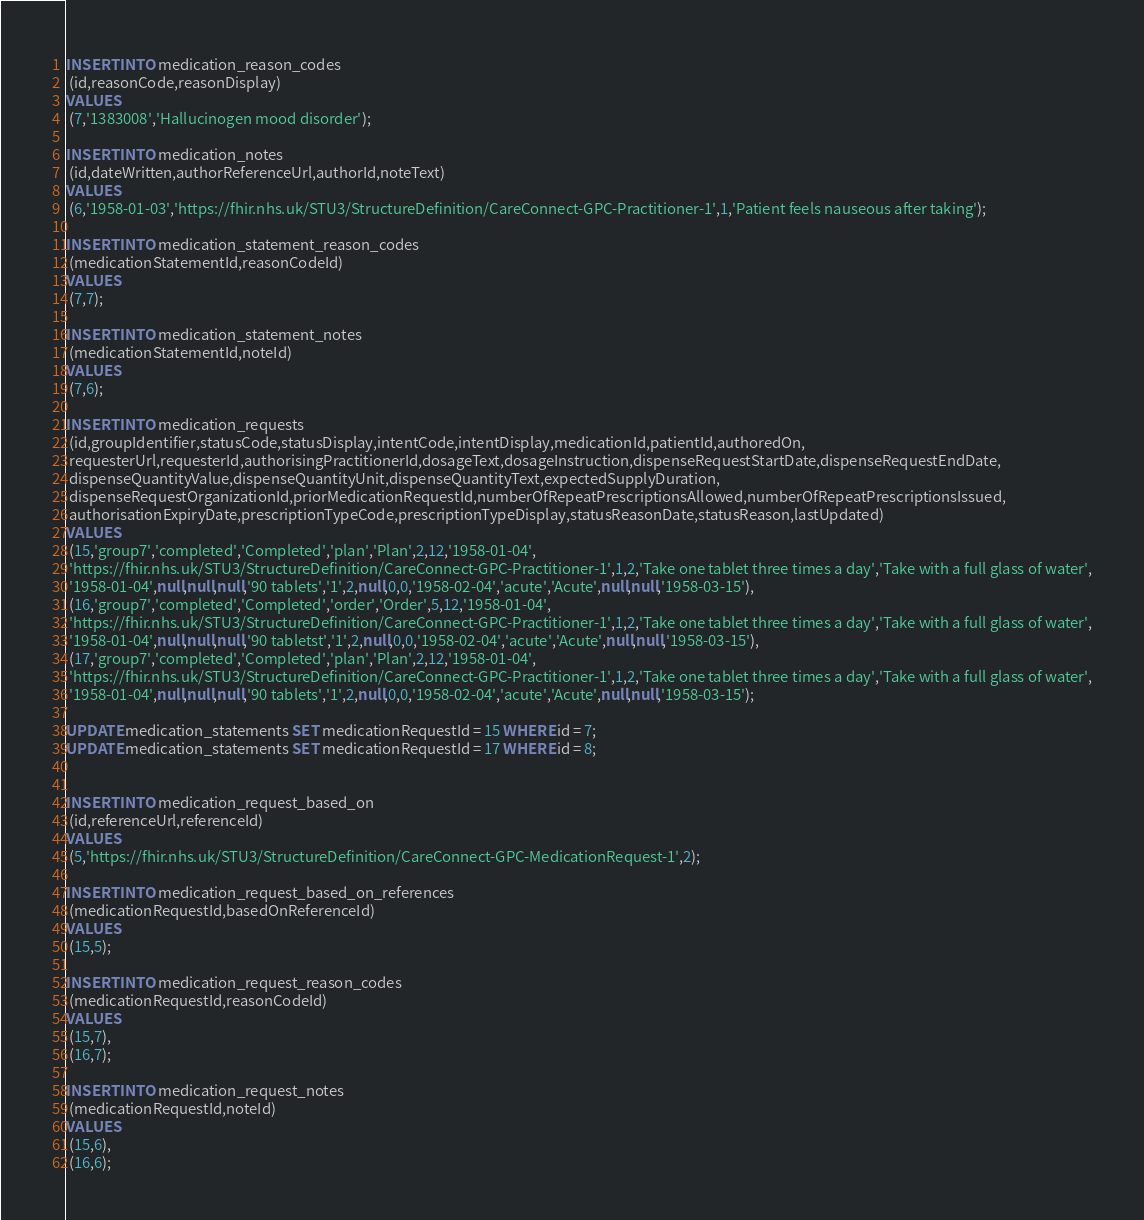Convert code to text. <code><loc_0><loc_0><loc_500><loc_500><_SQL_>INSERT INTO medication_reason_codes
 (id,reasonCode,reasonDisplay)
VALUES
 (7,'1383008','Hallucinogen mood disorder');

INSERT INTO medication_notes
 (id,dateWritten,authorReferenceUrl,authorId,noteText)
VALUES
 (6,'1958-01-03','https://fhir.nhs.uk/STU3/StructureDefinition/CareConnect-GPC-Practitioner-1',1,'Patient feels nauseous after taking');

INSERT INTO medication_statement_reason_codes
 (medicationStatementId,reasonCodeId)
VALUES
 (7,7);

INSERT INTO medication_statement_notes
 (medicationStatementId,noteId)
VALUES
 (7,6);

INSERT INTO medication_requests
 (id,groupIdentifier,statusCode,statusDisplay,intentCode,intentDisplay,medicationId,patientId,authoredOn,
 requesterUrl,requesterId,authorisingPractitionerId,dosageText,dosageInstruction,dispenseRequestStartDate,dispenseRequestEndDate,
 dispenseQuantityValue,dispenseQuantityUnit,dispenseQuantityText,expectedSupplyDuration,
 dispenseRequestOrganizationId,priorMedicationRequestId,numberOfRepeatPrescriptionsAllowed,numberOfRepeatPrescriptionsIssued,
 authorisationExpiryDate,prescriptionTypeCode,prescriptionTypeDisplay,statusReasonDate,statusReason,lastUpdated)
VALUES
 (15,'group7','completed','Completed','plan','Plan',2,12,'1958-01-04',
 'https://fhir.nhs.uk/STU3/StructureDefinition/CareConnect-GPC-Practitioner-1',1,2,'Take one tablet three times a day','Take with a full glass of water',
 '1958-01-04',null,null,null,'90 tablets','1',2,null,0,0,'1958-02-04','acute','Acute',null,null,'1958-03-15'),
 (16,'group7','completed','Completed','order','Order',5,12,'1958-01-04',
 'https://fhir.nhs.uk/STU3/StructureDefinition/CareConnect-GPC-Practitioner-1',1,2,'Take one tablet three times a day','Take with a full glass of water',
 '1958-01-04',null,null,null,'90 tabletst','1',2,null,0,0,'1958-02-04','acute','Acute',null,null,'1958-03-15'),
 (17,'group7','completed','Completed','plan','Plan',2,12,'1958-01-04',
 'https://fhir.nhs.uk/STU3/StructureDefinition/CareConnect-GPC-Practitioner-1',1,2,'Take one tablet three times a day','Take with a full glass of water',
 '1958-01-04',null,null,null,'90 tablets','1',2,null,0,0,'1958-02-04','acute','Acute',null,null,'1958-03-15');

UPDATE medication_statements SET medicationRequestId = 15 WHERE id = 7;
UPDATE medication_statements SET medicationRequestId = 17 WHERE id = 8;


INSERT INTO medication_request_based_on
 (id,referenceUrl,referenceId)
VALUES
 (5,'https://fhir.nhs.uk/STU3/StructureDefinition/CareConnect-GPC-MedicationRequest-1',2);

INSERT INTO medication_request_based_on_references
 (medicationRequestId,basedOnReferenceId)
VALUES
 (15,5);

INSERT INTO medication_request_reason_codes
 (medicationRequestId,reasonCodeId)
VALUES
 (15,7),
 (16,7);

INSERT INTO medication_request_notes
 (medicationRequestId,noteId)
VALUES
 (15,6),
 (16,6);
</code> 